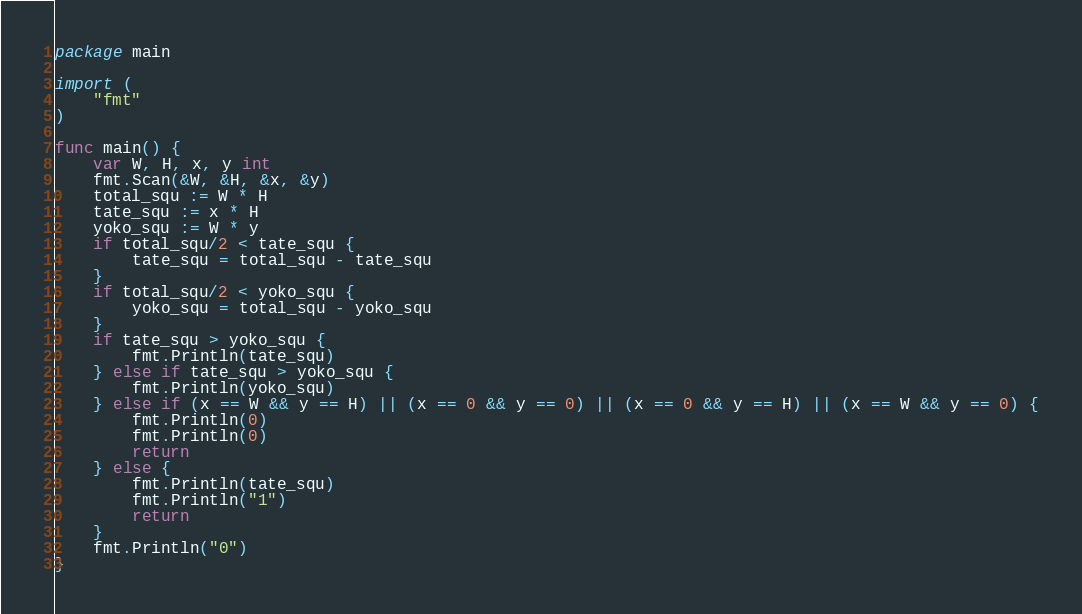Convert code to text. <code><loc_0><loc_0><loc_500><loc_500><_Go_>package main

import (
	"fmt"
)

func main() {
	var W, H, x, y int
	fmt.Scan(&W, &H, &x, &y)
	total_squ := W * H
	tate_squ := x * H
	yoko_squ := W * y
	if total_squ/2 < tate_squ {
		tate_squ = total_squ - tate_squ
	}
	if total_squ/2 < yoko_squ {
		yoko_squ = total_squ - yoko_squ
	}
	if tate_squ > yoko_squ {
		fmt.Println(tate_squ)
	} else if tate_squ > yoko_squ {
		fmt.Println(yoko_squ)
	} else if (x == W && y == H) || (x == 0 && y == 0) || (x == 0 && y == H) || (x == W && y == 0) {
		fmt.Println(0)
		fmt.Println(0)
		return
	} else {
		fmt.Println(tate_squ)
		fmt.Println("1")
		return
	}
	fmt.Println("0")
}
</code> 